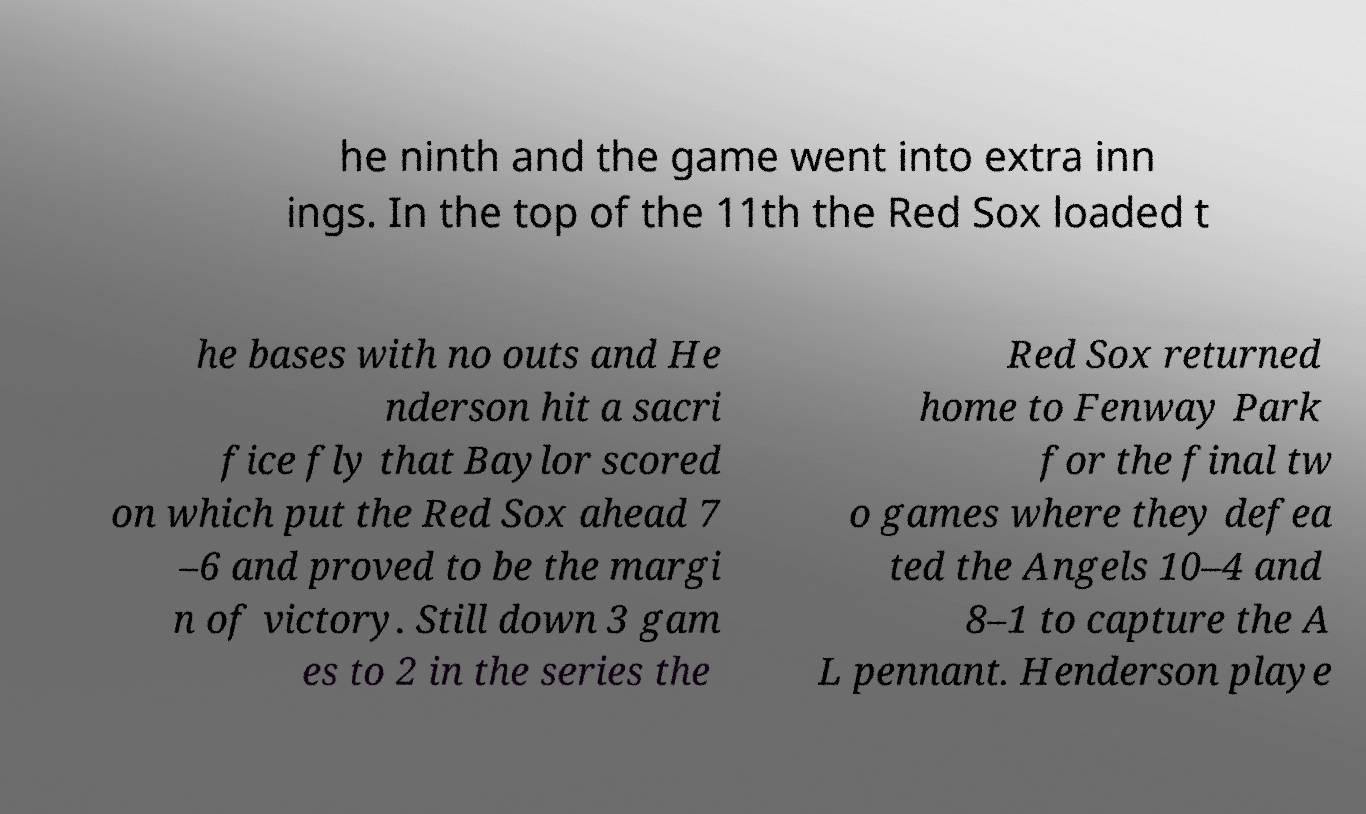Please identify and transcribe the text found in this image. he ninth and the game went into extra inn ings. In the top of the 11th the Red Sox loaded t he bases with no outs and He nderson hit a sacri fice fly that Baylor scored on which put the Red Sox ahead 7 –6 and proved to be the margi n of victory. Still down 3 gam es to 2 in the series the Red Sox returned home to Fenway Park for the final tw o games where they defea ted the Angels 10–4 and 8–1 to capture the A L pennant. Henderson playe 